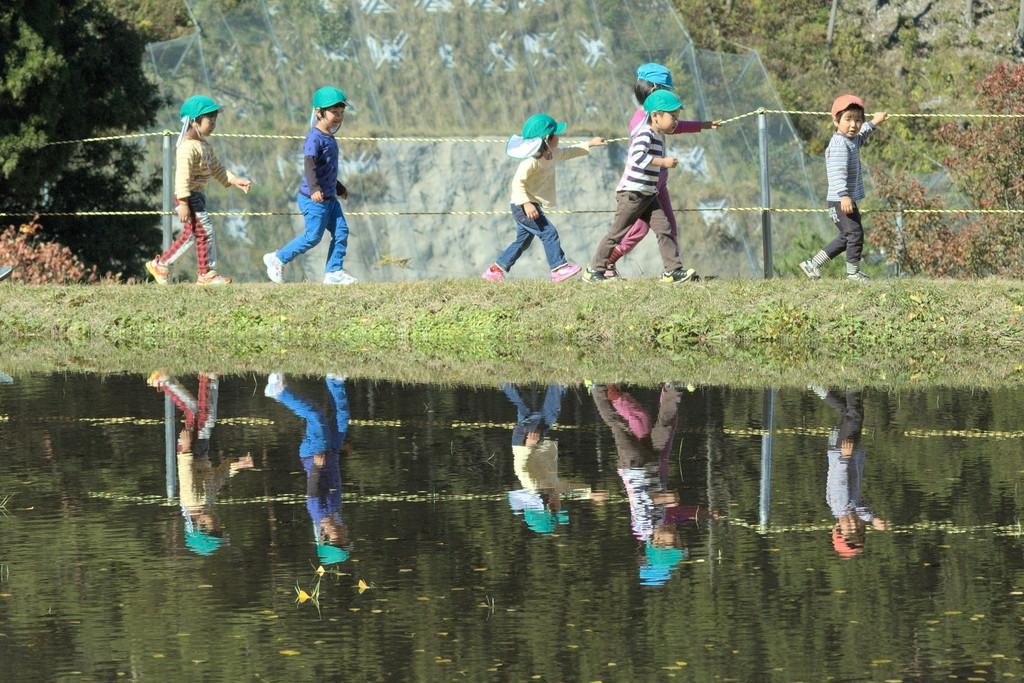What is present in the image? There are kids in the image. What are the kids doing? The kids are walking. What are the kids wearing on their heads? The kids are wearing caps. What type of terrain is visible in the image? There is grass and water visible in the image. What can be seen in the background of the image? There is rope fencing with poles and trees in the background. What type of bun can be seen in the image? There is no bun present in the image. How many clocks are visible in the image? There are no clocks visible in the image. 